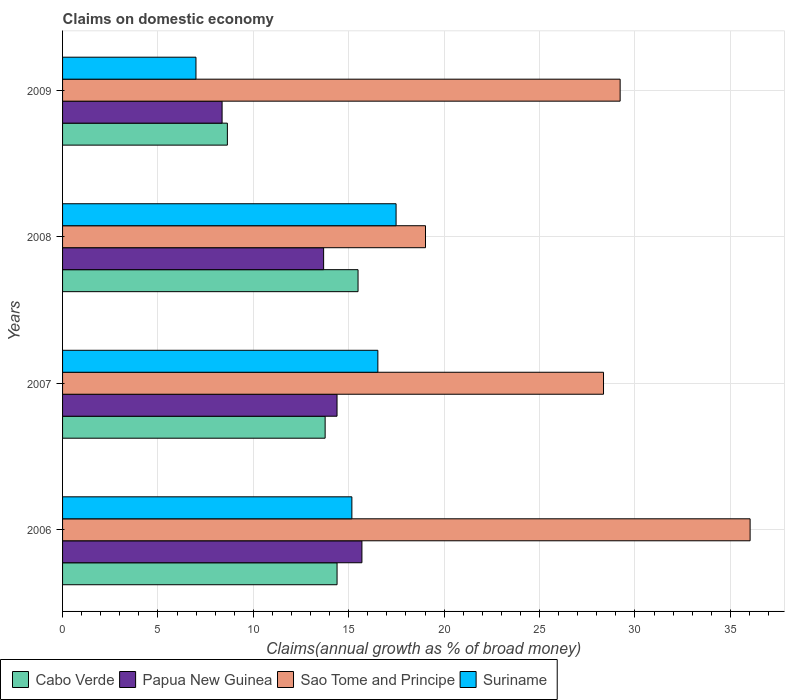How many different coloured bars are there?
Offer a terse response. 4. How many groups of bars are there?
Make the answer very short. 4. Are the number of bars per tick equal to the number of legend labels?
Your response must be concise. Yes. How many bars are there on the 1st tick from the top?
Your answer should be very brief. 4. How many bars are there on the 3rd tick from the bottom?
Your answer should be compact. 4. What is the label of the 1st group of bars from the top?
Your answer should be very brief. 2009. In how many cases, is the number of bars for a given year not equal to the number of legend labels?
Keep it short and to the point. 0. What is the percentage of broad money claimed on domestic economy in Cabo Verde in 2009?
Provide a succinct answer. 8.64. Across all years, what is the maximum percentage of broad money claimed on domestic economy in Suriname?
Your response must be concise. 17.48. Across all years, what is the minimum percentage of broad money claimed on domestic economy in Suriname?
Offer a terse response. 6.99. In which year was the percentage of broad money claimed on domestic economy in Suriname maximum?
Keep it short and to the point. 2008. What is the total percentage of broad money claimed on domestic economy in Sao Tome and Principe in the graph?
Offer a very short reply. 112.64. What is the difference between the percentage of broad money claimed on domestic economy in Suriname in 2008 and that in 2009?
Offer a very short reply. 10.49. What is the difference between the percentage of broad money claimed on domestic economy in Cabo Verde in 2006 and the percentage of broad money claimed on domestic economy in Suriname in 2007?
Provide a succinct answer. -2.14. What is the average percentage of broad money claimed on domestic economy in Cabo Verde per year?
Your answer should be very brief. 13.07. In the year 2006, what is the difference between the percentage of broad money claimed on domestic economy in Sao Tome and Principe and percentage of broad money claimed on domestic economy in Suriname?
Your answer should be compact. 20.87. In how many years, is the percentage of broad money claimed on domestic economy in Suriname greater than 21 %?
Provide a succinct answer. 0. What is the ratio of the percentage of broad money claimed on domestic economy in Cabo Verde in 2007 to that in 2008?
Keep it short and to the point. 0.89. Is the percentage of broad money claimed on domestic economy in Sao Tome and Principe in 2008 less than that in 2009?
Make the answer very short. Yes. What is the difference between the highest and the second highest percentage of broad money claimed on domestic economy in Suriname?
Provide a succinct answer. 0.96. What is the difference between the highest and the lowest percentage of broad money claimed on domestic economy in Cabo Verde?
Offer a very short reply. 6.85. In how many years, is the percentage of broad money claimed on domestic economy in Cabo Verde greater than the average percentage of broad money claimed on domestic economy in Cabo Verde taken over all years?
Offer a terse response. 3. Is the sum of the percentage of broad money claimed on domestic economy in Papua New Guinea in 2006 and 2009 greater than the maximum percentage of broad money claimed on domestic economy in Cabo Verde across all years?
Provide a short and direct response. Yes. Is it the case that in every year, the sum of the percentage of broad money claimed on domestic economy in Sao Tome and Principe and percentage of broad money claimed on domestic economy in Cabo Verde is greater than the sum of percentage of broad money claimed on domestic economy in Suriname and percentage of broad money claimed on domestic economy in Papua New Guinea?
Provide a succinct answer. Yes. What does the 4th bar from the top in 2008 represents?
Give a very brief answer. Cabo Verde. What does the 3rd bar from the bottom in 2009 represents?
Give a very brief answer. Sao Tome and Principe. Is it the case that in every year, the sum of the percentage of broad money claimed on domestic economy in Sao Tome and Principe and percentage of broad money claimed on domestic economy in Suriname is greater than the percentage of broad money claimed on domestic economy in Papua New Guinea?
Your answer should be compact. Yes. How many years are there in the graph?
Your answer should be very brief. 4. Does the graph contain any zero values?
Ensure brevity in your answer.  No. Does the graph contain grids?
Your answer should be very brief. Yes. How many legend labels are there?
Ensure brevity in your answer.  4. What is the title of the graph?
Your response must be concise. Claims on domestic economy. What is the label or title of the X-axis?
Keep it short and to the point. Claims(annual growth as % of broad money). What is the Claims(annual growth as % of broad money) in Cabo Verde in 2006?
Give a very brief answer. 14.39. What is the Claims(annual growth as % of broad money) of Papua New Guinea in 2006?
Give a very brief answer. 15.69. What is the Claims(annual growth as % of broad money) of Sao Tome and Principe in 2006?
Make the answer very short. 36.04. What is the Claims(annual growth as % of broad money) in Suriname in 2006?
Offer a very short reply. 15.16. What is the Claims(annual growth as % of broad money) of Cabo Verde in 2007?
Provide a succinct answer. 13.76. What is the Claims(annual growth as % of broad money) of Papua New Guinea in 2007?
Give a very brief answer. 14.39. What is the Claims(annual growth as % of broad money) in Sao Tome and Principe in 2007?
Your response must be concise. 28.35. What is the Claims(annual growth as % of broad money) in Suriname in 2007?
Provide a succinct answer. 16.53. What is the Claims(annual growth as % of broad money) in Cabo Verde in 2008?
Provide a succinct answer. 15.49. What is the Claims(annual growth as % of broad money) in Papua New Guinea in 2008?
Your response must be concise. 13.68. What is the Claims(annual growth as % of broad money) of Sao Tome and Principe in 2008?
Offer a terse response. 19.02. What is the Claims(annual growth as % of broad money) of Suriname in 2008?
Provide a short and direct response. 17.48. What is the Claims(annual growth as % of broad money) of Cabo Verde in 2009?
Ensure brevity in your answer.  8.64. What is the Claims(annual growth as % of broad money) of Papua New Guinea in 2009?
Give a very brief answer. 8.36. What is the Claims(annual growth as % of broad money) in Sao Tome and Principe in 2009?
Ensure brevity in your answer.  29.23. What is the Claims(annual growth as % of broad money) of Suriname in 2009?
Ensure brevity in your answer.  6.99. Across all years, what is the maximum Claims(annual growth as % of broad money) of Cabo Verde?
Provide a succinct answer. 15.49. Across all years, what is the maximum Claims(annual growth as % of broad money) in Papua New Guinea?
Your answer should be very brief. 15.69. Across all years, what is the maximum Claims(annual growth as % of broad money) in Sao Tome and Principe?
Provide a short and direct response. 36.04. Across all years, what is the maximum Claims(annual growth as % of broad money) of Suriname?
Offer a very short reply. 17.48. Across all years, what is the minimum Claims(annual growth as % of broad money) in Cabo Verde?
Ensure brevity in your answer.  8.64. Across all years, what is the minimum Claims(annual growth as % of broad money) in Papua New Guinea?
Ensure brevity in your answer.  8.36. Across all years, what is the minimum Claims(annual growth as % of broad money) in Sao Tome and Principe?
Your answer should be very brief. 19.02. Across all years, what is the minimum Claims(annual growth as % of broad money) of Suriname?
Give a very brief answer. 6.99. What is the total Claims(annual growth as % of broad money) of Cabo Verde in the graph?
Your answer should be very brief. 52.28. What is the total Claims(annual growth as % of broad money) in Papua New Guinea in the graph?
Give a very brief answer. 52.12. What is the total Claims(annual growth as % of broad money) of Sao Tome and Principe in the graph?
Give a very brief answer. 112.64. What is the total Claims(annual growth as % of broad money) in Suriname in the graph?
Provide a succinct answer. 56.16. What is the difference between the Claims(annual growth as % of broad money) of Cabo Verde in 2006 and that in 2007?
Provide a succinct answer. 0.62. What is the difference between the Claims(annual growth as % of broad money) of Papua New Guinea in 2006 and that in 2007?
Keep it short and to the point. 1.3. What is the difference between the Claims(annual growth as % of broad money) in Sao Tome and Principe in 2006 and that in 2007?
Offer a very short reply. 7.68. What is the difference between the Claims(annual growth as % of broad money) of Suriname in 2006 and that in 2007?
Your answer should be compact. -1.36. What is the difference between the Claims(annual growth as % of broad money) of Cabo Verde in 2006 and that in 2008?
Offer a terse response. -1.1. What is the difference between the Claims(annual growth as % of broad money) in Papua New Guinea in 2006 and that in 2008?
Offer a terse response. 2.01. What is the difference between the Claims(annual growth as % of broad money) in Sao Tome and Principe in 2006 and that in 2008?
Your answer should be compact. 17.01. What is the difference between the Claims(annual growth as % of broad money) in Suriname in 2006 and that in 2008?
Provide a short and direct response. -2.32. What is the difference between the Claims(annual growth as % of broad money) in Cabo Verde in 2006 and that in 2009?
Your answer should be compact. 5.75. What is the difference between the Claims(annual growth as % of broad money) of Papua New Guinea in 2006 and that in 2009?
Provide a short and direct response. 7.33. What is the difference between the Claims(annual growth as % of broad money) of Sao Tome and Principe in 2006 and that in 2009?
Make the answer very short. 6.81. What is the difference between the Claims(annual growth as % of broad money) of Suriname in 2006 and that in 2009?
Your answer should be compact. 8.17. What is the difference between the Claims(annual growth as % of broad money) of Cabo Verde in 2007 and that in 2008?
Offer a very short reply. -1.72. What is the difference between the Claims(annual growth as % of broad money) in Papua New Guinea in 2007 and that in 2008?
Offer a terse response. 0.7. What is the difference between the Claims(annual growth as % of broad money) of Sao Tome and Principe in 2007 and that in 2008?
Ensure brevity in your answer.  9.33. What is the difference between the Claims(annual growth as % of broad money) of Suriname in 2007 and that in 2008?
Keep it short and to the point. -0.96. What is the difference between the Claims(annual growth as % of broad money) of Cabo Verde in 2007 and that in 2009?
Provide a succinct answer. 5.12. What is the difference between the Claims(annual growth as % of broad money) of Papua New Guinea in 2007 and that in 2009?
Provide a short and direct response. 6.02. What is the difference between the Claims(annual growth as % of broad money) of Sao Tome and Principe in 2007 and that in 2009?
Keep it short and to the point. -0.87. What is the difference between the Claims(annual growth as % of broad money) of Suriname in 2007 and that in 2009?
Make the answer very short. 9.53. What is the difference between the Claims(annual growth as % of broad money) of Cabo Verde in 2008 and that in 2009?
Provide a short and direct response. 6.85. What is the difference between the Claims(annual growth as % of broad money) in Papua New Guinea in 2008 and that in 2009?
Offer a very short reply. 5.32. What is the difference between the Claims(annual growth as % of broad money) in Sao Tome and Principe in 2008 and that in 2009?
Give a very brief answer. -10.2. What is the difference between the Claims(annual growth as % of broad money) in Suriname in 2008 and that in 2009?
Ensure brevity in your answer.  10.49. What is the difference between the Claims(annual growth as % of broad money) of Cabo Verde in 2006 and the Claims(annual growth as % of broad money) of Papua New Guinea in 2007?
Your response must be concise. 0. What is the difference between the Claims(annual growth as % of broad money) in Cabo Verde in 2006 and the Claims(annual growth as % of broad money) in Sao Tome and Principe in 2007?
Provide a short and direct response. -13.97. What is the difference between the Claims(annual growth as % of broad money) in Cabo Verde in 2006 and the Claims(annual growth as % of broad money) in Suriname in 2007?
Keep it short and to the point. -2.14. What is the difference between the Claims(annual growth as % of broad money) of Papua New Guinea in 2006 and the Claims(annual growth as % of broad money) of Sao Tome and Principe in 2007?
Your answer should be compact. -12.66. What is the difference between the Claims(annual growth as % of broad money) of Papua New Guinea in 2006 and the Claims(annual growth as % of broad money) of Suriname in 2007?
Provide a succinct answer. -0.84. What is the difference between the Claims(annual growth as % of broad money) of Sao Tome and Principe in 2006 and the Claims(annual growth as % of broad money) of Suriname in 2007?
Your response must be concise. 19.51. What is the difference between the Claims(annual growth as % of broad money) of Cabo Verde in 2006 and the Claims(annual growth as % of broad money) of Papua New Guinea in 2008?
Keep it short and to the point. 0.7. What is the difference between the Claims(annual growth as % of broad money) in Cabo Verde in 2006 and the Claims(annual growth as % of broad money) in Sao Tome and Principe in 2008?
Keep it short and to the point. -4.64. What is the difference between the Claims(annual growth as % of broad money) of Cabo Verde in 2006 and the Claims(annual growth as % of broad money) of Suriname in 2008?
Ensure brevity in your answer.  -3.09. What is the difference between the Claims(annual growth as % of broad money) of Papua New Guinea in 2006 and the Claims(annual growth as % of broad money) of Sao Tome and Principe in 2008?
Offer a very short reply. -3.33. What is the difference between the Claims(annual growth as % of broad money) of Papua New Guinea in 2006 and the Claims(annual growth as % of broad money) of Suriname in 2008?
Give a very brief answer. -1.79. What is the difference between the Claims(annual growth as % of broad money) of Sao Tome and Principe in 2006 and the Claims(annual growth as % of broad money) of Suriname in 2008?
Offer a very short reply. 18.56. What is the difference between the Claims(annual growth as % of broad money) in Cabo Verde in 2006 and the Claims(annual growth as % of broad money) in Papua New Guinea in 2009?
Make the answer very short. 6.03. What is the difference between the Claims(annual growth as % of broad money) of Cabo Verde in 2006 and the Claims(annual growth as % of broad money) of Sao Tome and Principe in 2009?
Your answer should be compact. -14.84. What is the difference between the Claims(annual growth as % of broad money) in Cabo Verde in 2006 and the Claims(annual growth as % of broad money) in Suriname in 2009?
Offer a terse response. 7.39. What is the difference between the Claims(annual growth as % of broad money) in Papua New Guinea in 2006 and the Claims(annual growth as % of broad money) in Sao Tome and Principe in 2009?
Your response must be concise. -13.53. What is the difference between the Claims(annual growth as % of broad money) of Papua New Guinea in 2006 and the Claims(annual growth as % of broad money) of Suriname in 2009?
Offer a very short reply. 8.7. What is the difference between the Claims(annual growth as % of broad money) of Sao Tome and Principe in 2006 and the Claims(annual growth as % of broad money) of Suriname in 2009?
Your answer should be very brief. 29.05. What is the difference between the Claims(annual growth as % of broad money) of Cabo Verde in 2007 and the Claims(annual growth as % of broad money) of Papua New Guinea in 2008?
Your answer should be compact. 0.08. What is the difference between the Claims(annual growth as % of broad money) of Cabo Verde in 2007 and the Claims(annual growth as % of broad money) of Sao Tome and Principe in 2008?
Your answer should be very brief. -5.26. What is the difference between the Claims(annual growth as % of broad money) in Cabo Verde in 2007 and the Claims(annual growth as % of broad money) in Suriname in 2008?
Give a very brief answer. -3.72. What is the difference between the Claims(annual growth as % of broad money) of Papua New Guinea in 2007 and the Claims(annual growth as % of broad money) of Sao Tome and Principe in 2008?
Give a very brief answer. -4.64. What is the difference between the Claims(annual growth as % of broad money) in Papua New Guinea in 2007 and the Claims(annual growth as % of broad money) in Suriname in 2008?
Your answer should be compact. -3.1. What is the difference between the Claims(annual growth as % of broad money) of Sao Tome and Principe in 2007 and the Claims(annual growth as % of broad money) of Suriname in 2008?
Provide a succinct answer. 10.87. What is the difference between the Claims(annual growth as % of broad money) in Cabo Verde in 2007 and the Claims(annual growth as % of broad money) in Papua New Guinea in 2009?
Your answer should be compact. 5.4. What is the difference between the Claims(annual growth as % of broad money) of Cabo Verde in 2007 and the Claims(annual growth as % of broad money) of Sao Tome and Principe in 2009?
Ensure brevity in your answer.  -15.46. What is the difference between the Claims(annual growth as % of broad money) of Cabo Verde in 2007 and the Claims(annual growth as % of broad money) of Suriname in 2009?
Ensure brevity in your answer.  6.77. What is the difference between the Claims(annual growth as % of broad money) in Papua New Guinea in 2007 and the Claims(annual growth as % of broad money) in Sao Tome and Principe in 2009?
Offer a very short reply. -14.84. What is the difference between the Claims(annual growth as % of broad money) in Papua New Guinea in 2007 and the Claims(annual growth as % of broad money) in Suriname in 2009?
Offer a very short reply. 7.39. What is the difference between the Claims(annual growth as % of broad money) of Sao Tome and Principe in 2007 and the Claims(annual growth as % of broad money) of Suriname in 2009?
Offer a terse response. 21.36. What is the difference between the Claims(annual growth as % of broad money) in Cabo Verde in 2008 and the Claims(annual growth as % of broad money) in Papua New Guinea in 2009?
Provide a short and direct response. 7.13. What is the difference between the Claims(annual growth as % of broad money) of Cabo Verde in 2008 and the Claims(annual growth as % of broad money) of Sao Tome and Principe in 2009?
Provide a short and direct response. -13.74. What is the difference between the Claims(annual growth as % of broad money) in Cabo Verde in 2008 and the Claims(annual growth as % of broad money) in Suriname in 2009?
Give a very brief answer. 8.49. What is the difference between the Claims(annual growth as % of broad money) of Papua New Guinea in 2008 and the Claims(annual growth as % of broad money) of Sao Tome and Principe in 2009?
Provide a short and direct response. -15.54. What is the difference between the Claims(annual growth as % of broad money) of Papua New Guinea in 2008 and the Claims(annual growth as % of broad money) of Suriname in 2009?
Your answer should be compact. 6.69. What is the difference between the Claims(annual growth as % of broad money) of Sao Tome and Principe in 2008 and the Claims(annual growth as % of broad money) of Suriname in 2009?
Your response must be concise. 12.03. What is the average Claims(annual growth as % of broad money) in Cabo Verde per year?
Ensure brevity in your answer.  13.07. What is the average Claims(annual growth as % of broad money) in Papua New Guinea per year?
Your answer should be compact. 13.03. What is the average Claims(annual growth as % of broad money) in Sao Tome and Principe per year?
Provide a succinct answer. 28.16. What is the average Claims(annual growth as % of broad money) in Suriname per year?
Your response must be concise. 14.04. In the year 2006, what is the difference between the Claims(annual growth as % of broad money) in Cabo Verde and Claims(annual growth as % of broad money) in Papua New Guinea?
Give a very brief answer. -1.3. In the year 2006, what is the difference between the Claims(annual growth as % of broad money) in Cabo Verde and Claims(annual growth as % of broad money) in Sao Tome and Principe?
Your answer should be very brief. -21.65. In the year 2006, what is the difference between the Claims(annual growth as % of broad money) of Cabo Verde and Claims(annual growth as % of broad money) of Suriname?
Your answer should be compact. -0.78. In the year 2006, what is the difference between the Claims(annual growth as % of broad money) of Papua New Guinea and Claims(annual growth as % of broad money) of Sao Tome and Principe?
Make the answer very short. -20.35. In the year 2006, what is the difference between the Claims(annual growth as % of broad money) in Papua New Guinea and Claims(annual growth as % of broad money) in Suriname?
Ensure brevity in your answer.  0.53. In the year 2006, what is the difference between the Claims(annual growth as % of broad money) in Sao Tome and Principe and Claims(annual growth as % of broad money) in Suriname?
Provide a short and direct response. 20.87. In the year 2007, what is the difference between the Claims(annual growth as % of broad money) in Cabo Verde and Claims(annual growth as % of broad money) in Papua New Guinea?
Your answer should be compact. -0.62. In the year 2007, what is the difference between the Claims(annual growth as % of broad money) in Cabo Verde and Claims(annual growth as % of broad money) in Sao Tome and Principe?
Provide a succinct answer. -14.59. In the year 2007, what is the difference between the Claims(annual growth as % of broad money) of Cabo Verde and Claims(annual growth as % of broad money) of Suriname?
Keep it short and to the point. -2.76. In the year 2007, what is the difference between the Claims(annual growth as % of broad money) of Papua New Guinea and Claims(annual growth as % of broad money) of Sao Tome and Principe?
Your answer should be very brief. -13.97. In the year 2007, what is the difference between the Claims(annual growth as % of broad money) in Papua New Guinea and Claims(annual growth as % of broad money) in Suriname?
Give a very brief answer. -2.14. In the year 2007, what is the difference between the Claims(annual growth as % of broad money) of Sao Tome and Principe and Claims(annual growth as % of broad money) of Suriname?
Offer a terse response. 11.83. In the year 2008, what is the difference between the Claims(annual growth as % of broad money) in Cabo Verde and Claims(annual growth as % of broad money) in Papua New Guinea?
Offer a very short reply. 1.8. In the year 2008, what is the difference between the Claims(annual growth as % of broad money) in Cabo Verde and Claims(annual growth as % of broad money) in Sao Tome and Principe?
Offer a terse response. -3.54. In the year 2008, what is the difference between the Claims(annual growth as % of broad money) of Cabo Verde and Claims(annual growth as % of broad money) of Suriname?
Keep it short and to the point. -1.99. In the year 2008, what is the difference between the Claims(annual growth as % of broad money) in Papua New Guinea and Claims(annual growth as % of broad money) in Sao Tome and Principe?
Your answer should be very brief. -5.34. In the year 2008, what is the difference between the Claims(annual growth as % of broad money) in Papua New Guinea and Claims(annual growth as % of broad money) in Suriname?
Keep it short and to the point. -3.8. In the year 2008, what is the difference between the Claims(annual growth as % of broad money) in Sao Tome and Principe and Claims(annual growth as % of broad money) in Suriname?
Offer a very short reply. 1.54. In the year 2009, what is the difference between the Claims(annual growth as % of broad money) in Cabo Verde and Claims(annual growth as % of broad money) in Papua New Guinea?
Provide a succinct answer. 0.28. In the year 2009, what is the difference between the Claims(annual growth as % of broad money) of Cabo Verde and Claims(annual growth as % of broad money) of Sao Tome and Principe?
Your answer should be very brief. -20.59. In the year 2009, what is the difference between the Claims(annual growth as % of broad money) in Cabo Verde and Claims(annual growth as % of broad money) in Suriname?
Offer a very short reply. 1.65. In the year 2009, what is the difference between the Claims(annual growth as % of broad money) in Papua New Guinea and Claims(annual growth as % of broad money) in Sao Tome and Principe?
Provide a short and direct response. -20.86. In the year 2009, what is the difference between the Claims(annual growth as % of broad money) of Papua New Guinea and Claims(annual growth as % of broad money) of Suriname?
Your response must be concise. 1.37. In the year 2009, what is the difference between the Claims(annual growth as % of broad money) in Sao Tome and Principe and Claims(annual growth as % of broad money) in Suriname?
Give a very brief answer. 22.23. What is the ratio of the Claims(annual growth as % of broad money) in Cabo Verde in 2006 to that in 2007?
Provide a short and direct response. 1.05. What is the ratio of the Claims(annual growth as % of broad money) in Papua New Guinea in 2006 to that in 2007?
Your response must be concise. 1.09. What is the ratio of the Claims(annual growth as % of broad money) of Sao Tome and Principe in 2006 to that in 2007?
Give a very brief answer. 1.27. What is the ratio of the Claims(annual growth as % of broad money) of Suriname in 2006 to that in 2007?
Provide a short and direct response. 0.92. What is the ratio of the Claims(annual growth as % of broad money) of Cabo Verde in 2006 to that in 2008?
Provide a short and direct response. 0.93. What is the ratio of the Claims(annual growth as % of broad money) in Papua New Guinea in 2006 to that in 2008?
Keep it short and to the point. 1.15. What is the ratio of the Claims(annual growth as % of broad money) of Sao Tome and Principe in 2006 to that in 2008?
Keep it short and to the point. 1.89. What is the ratio of the Claims(annual growth as % of broad money) in Suriname in 2006 to that in 2008?
Provide a short and direct response. 0.87. What is the ratio of the Claims(annual growth as % of broad money) in Cabo Verde in 2006 to that in 2009?
Provide a short and direct response. 1.67. What is the ratio of the Claims(annual growth as % of broad money) of Papua New Guinea in 2006 to that in 2009?
Your answer should be compact. 1.88. What is the ratio of the Claims(annual growth as % of broad money) of Sao Tome and Principe in 2006 to that in 2009?
Your answer should be compact. 1.23. What is the ratio of the Claims(annual growth as % of broad money) of Suriname in 2006 to that in 2009?
Your answer should be compact. 2.17. What is the ratio of the Claims(annual growth as % of broad money) in Cabo Verde in 2007 to that in 2008?
Offer a terse response. 0.89. What is the ratio of the Claims(annual growth as % of broad money) of Papua New Guinea in 2007 to that in 2008?
Give a very brief answer. 1.05. What is the ratio of the Claims(annual growth as % of broad money) in Sao Tome and Principe in 2007 to that in 2008?
Your response must be concise. 1.49. What is the ratio of the Claims(annual growth as % of broad money) of Suriname in 2007 to that in 2008?
Keep it short and to the point. 0.95. What is the ratio of the Claims(annual growth as % of broad money) of Cabo Verde in 2007 to that in 2009?
Offer a very short reply. 1.59. What is the ratio of the Claims(annual growth as % of broad money) in Papua New Guinea in 2007 to that in 2009?
Make the answer very short. 1.72. What is the ratio of the Claims(annual growth as % of broad money) in Sao Tome and Principe in 2007 to that in 2009?
Give a very brief answer. 0.97. What is the ratio of the Claims(annual growth as % of broad money) of Suriname in 2007 to that in 2009?
Your answer should be very brief. 2.36. What is the ratio of the Claims(annual growth as % of broad money) of Cabo Verde in 2008 to that in 2009?
Your response must be concise. 1.79. What is the ratio of the Claims(annual growth as % of broad money) of Papua New Guinea in 2008 to that in 2009?
Offer a terse response. 1.64. What is the ratio of the Claims(annual growth as % of broad money) in Sao Tome and Principe in 2008 to that in 2009?
Provide a short and direct response. 0.65. What is the difference between the highest and the second highest Claims(annual growth as % of broad money) of Cabo Verde?
Ensure brevity in your answer.  1.1. What is the difference between the highest and the second highest Claims(annual growth as % of broad money) of Papua New Guinea?
Ensure brevity in your answer.  1.3. What is the difference between the highest and the second highest Claims(annual growth as % of broad money) of Sao Tome and Principe?
Offer a terse response. 6.81. What is the difference between the highest and the second highest Claims(annual growth as % of broad money) of Suriname?
Make the answer very short. 0.96. What is the difference between the highest and the lowest Claims(annual growth as % of broad money) of Cabo Verde?
Give a very brief answer. 6.85. What is the difference between the highest and the lowest Claims(annual growth as % of broad money) in Papua New Guinea?
Offer a very short reply. 7.33. What is the difference between the highest and the lowest Claims(annual growth as % of broad money) in Sao Tome and Principe?
Your answer should be very brief. 17.01. What is the difference between the highest and the lowest Claims(annual growth as % of broad money) in Suriname?
Your response must be concise. 10.49. 